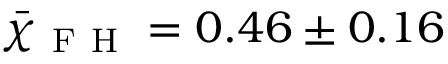Convert formula to latex. <formula><loc_0><loc_0><loc_500><loc_500>\bar { \chi } _ { F H } = 0 . 4 6 \pm 0 . 1 6</formula> 